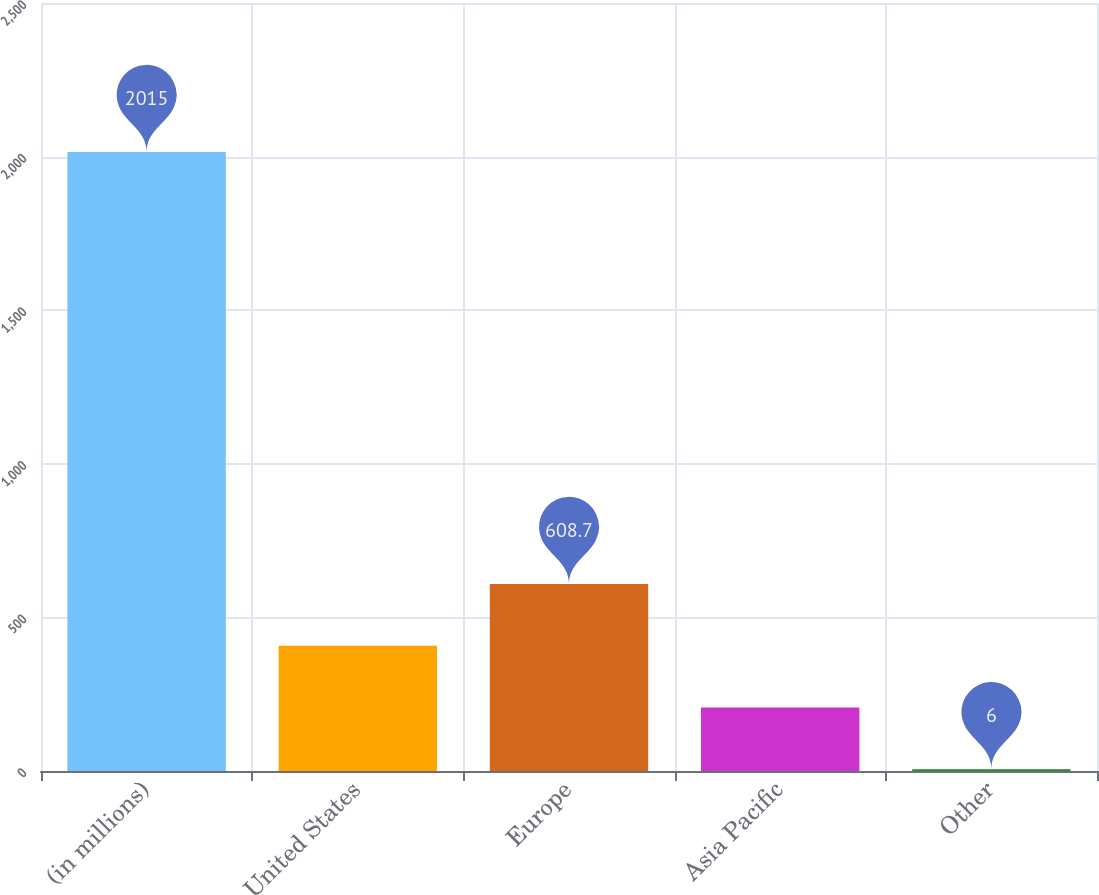Convert chart to OTSL. <chart><loc_0><loc_0><loc_500><loc_500><bar_chart><fcel>(in millions)<fcel>United States<fcel>Europe<fcel>Asia Pacific<fcel>Other<nl><fcel>2015<fcel>407.8<fcel>608.7<fcel>206.9<fcel>6<nl></chart> 